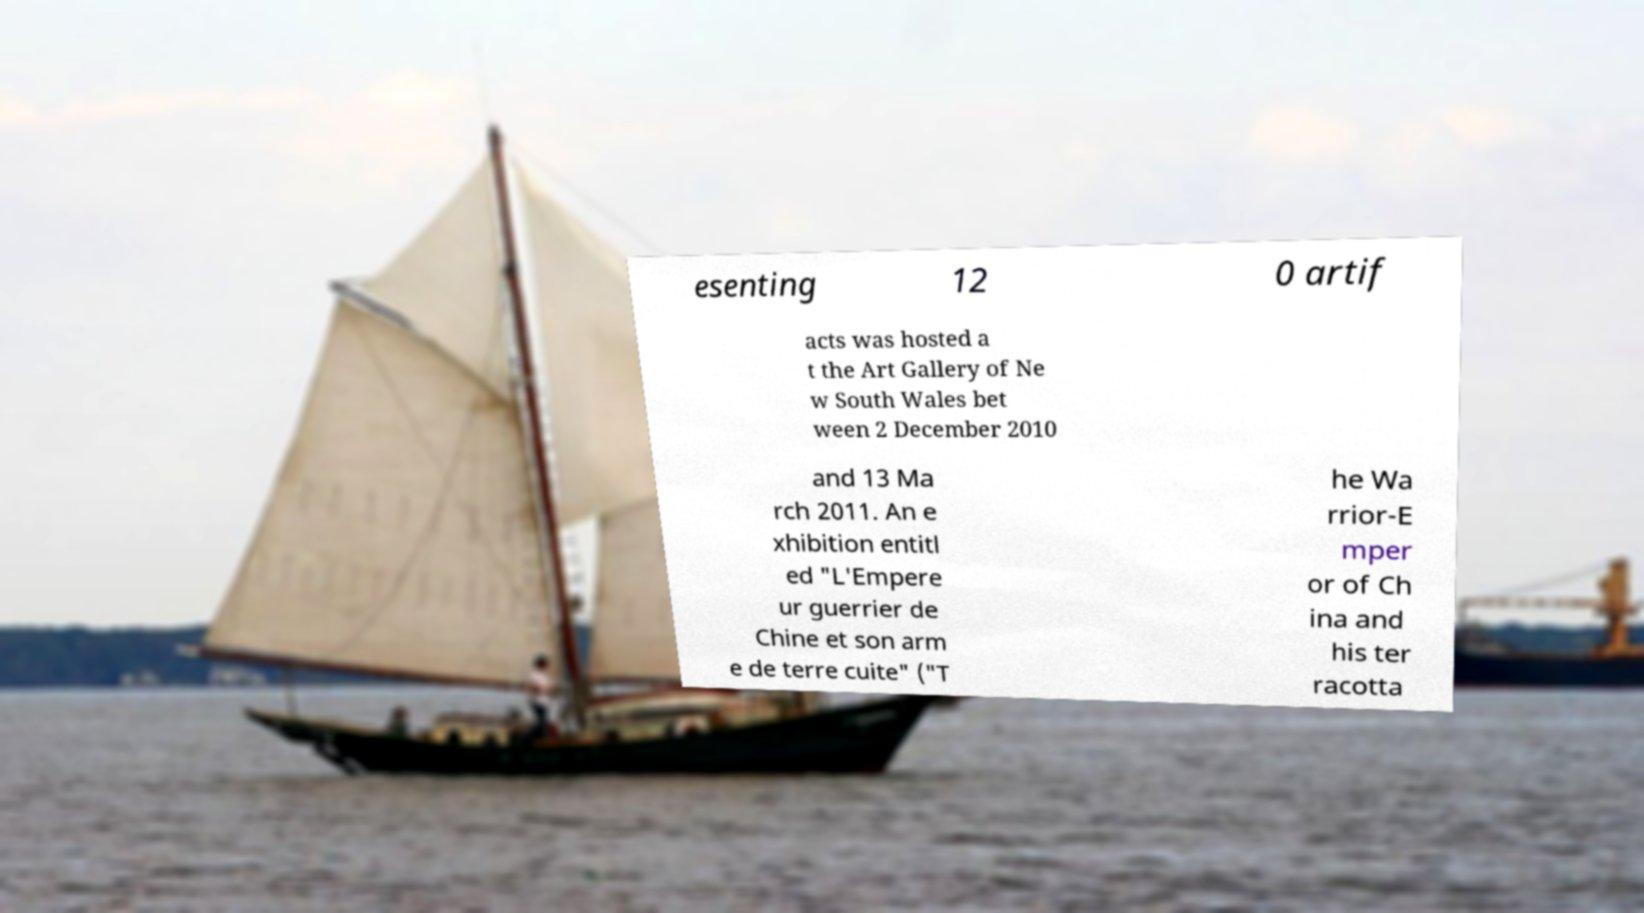I need the written content from this picture converted into text. Can you do that? esenting 12 0 artif acts was hosted a t the Art Gallery of Ne w South Wales bet ween 2 December 2010 and 13 Ma rch 2011. An e xhibition entitl ed "L'Empere ur guerrier de Chine et son arm e de terre cuite" ("T he Wa rrior-E mper or of Ch ina and his ter racotta 